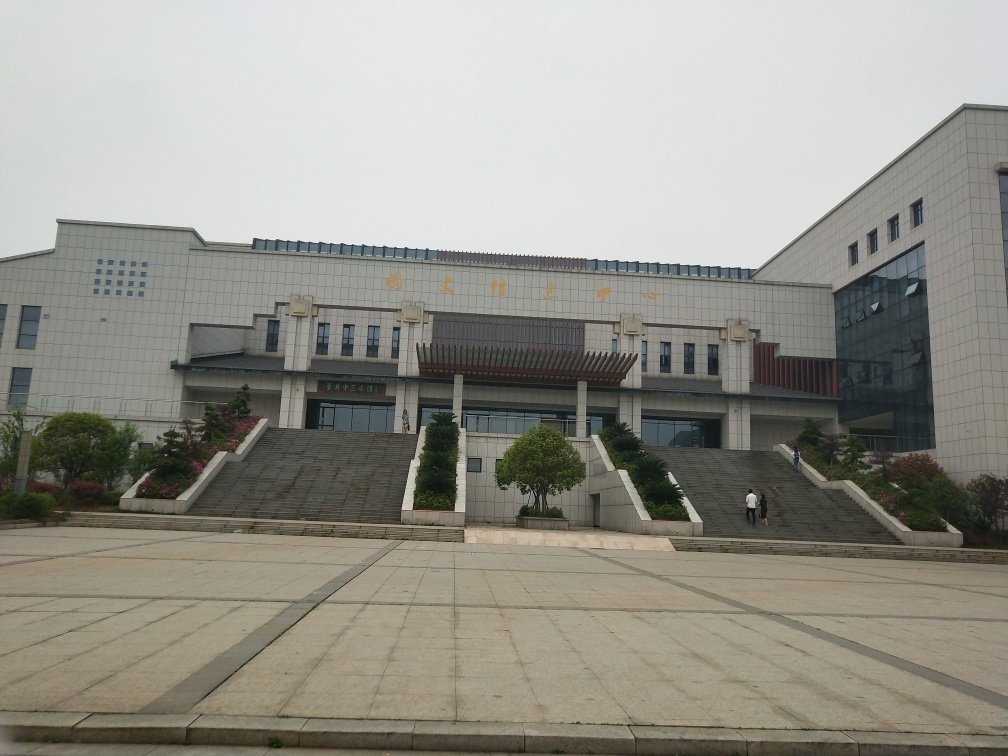Do both the subject and the background retain most of the texture details? The image shows a high level of textural detail in both the foreground subject, which is the building with its intricate architectural features, and the background, including the trees, the sky, and the pavement. The photo's resolution and clarity allow these details to be appreciated fully. 